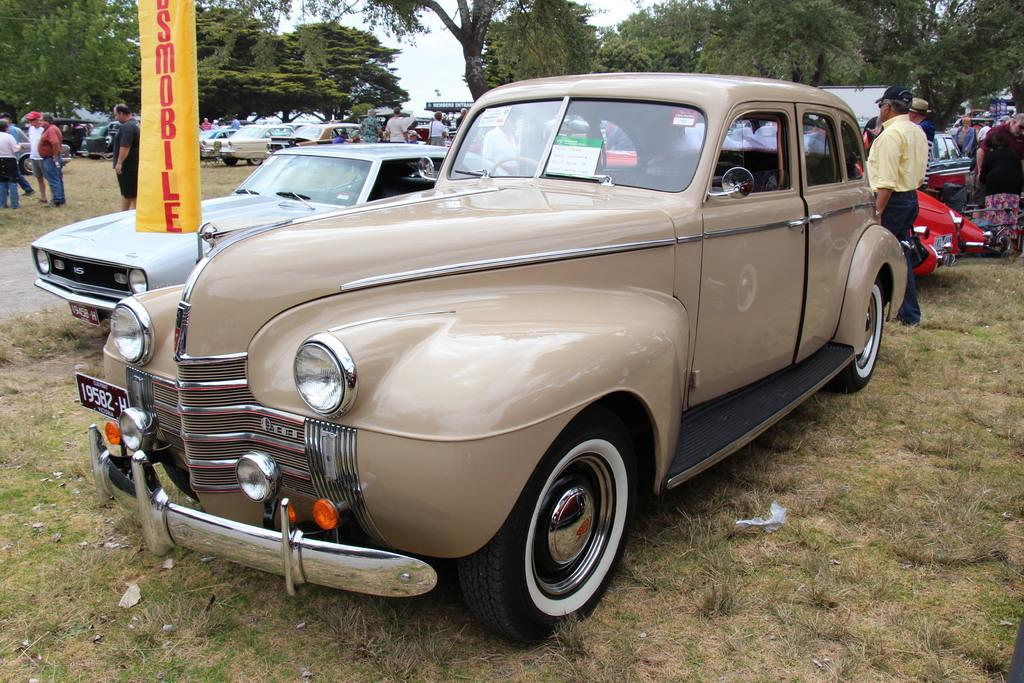What type of vehicles can be seen in the image? There are cars in the image. Who or what else is present in the image? There are people in the image. What type of natural environment is visible at the bottom of the image? There is grass at the bottom of the image. What can be seen in the background of the image? There are trees and sky visible in the background of the image. What object can be seen in the image that is not a car or a person? There is a board in the image. What type of fire can be seen in the image? There is no fire present in the image. Who is the mother of the people in the image? The provided facts do not mention any specific individuals or relationships, so it is not possible to determine who the mother of the people in the image might be. 